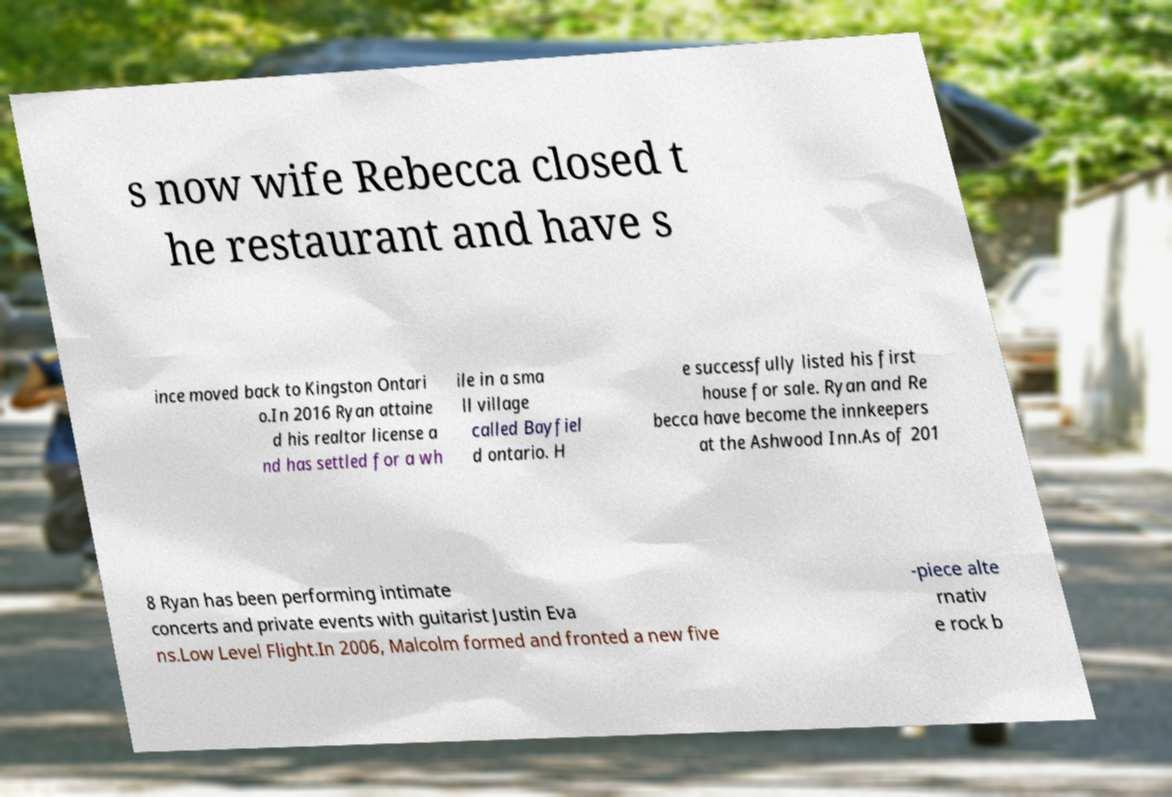For documentation purposes, I need the text within this image transcribed. Could you provide that? s now wife Rebecca closed t he restaurant and have s ince moved back to Kingston Ontari o.In 2016 Ryan attaine d his realtor license a nd has settled for a wh ile in a sma ll village called Bayfiel d ontario. H e successfully listed his first house for sale. Ryan and Re becca have become the innkeepers at the Ashwood Inn.As of 201 8 Ryan has been performing intimate concerts and private events with guitarist Justin Eva ns.Low Level Flight.In 2006, Malcolm formed and fronted a new five -piece alte rnativ e rock b 